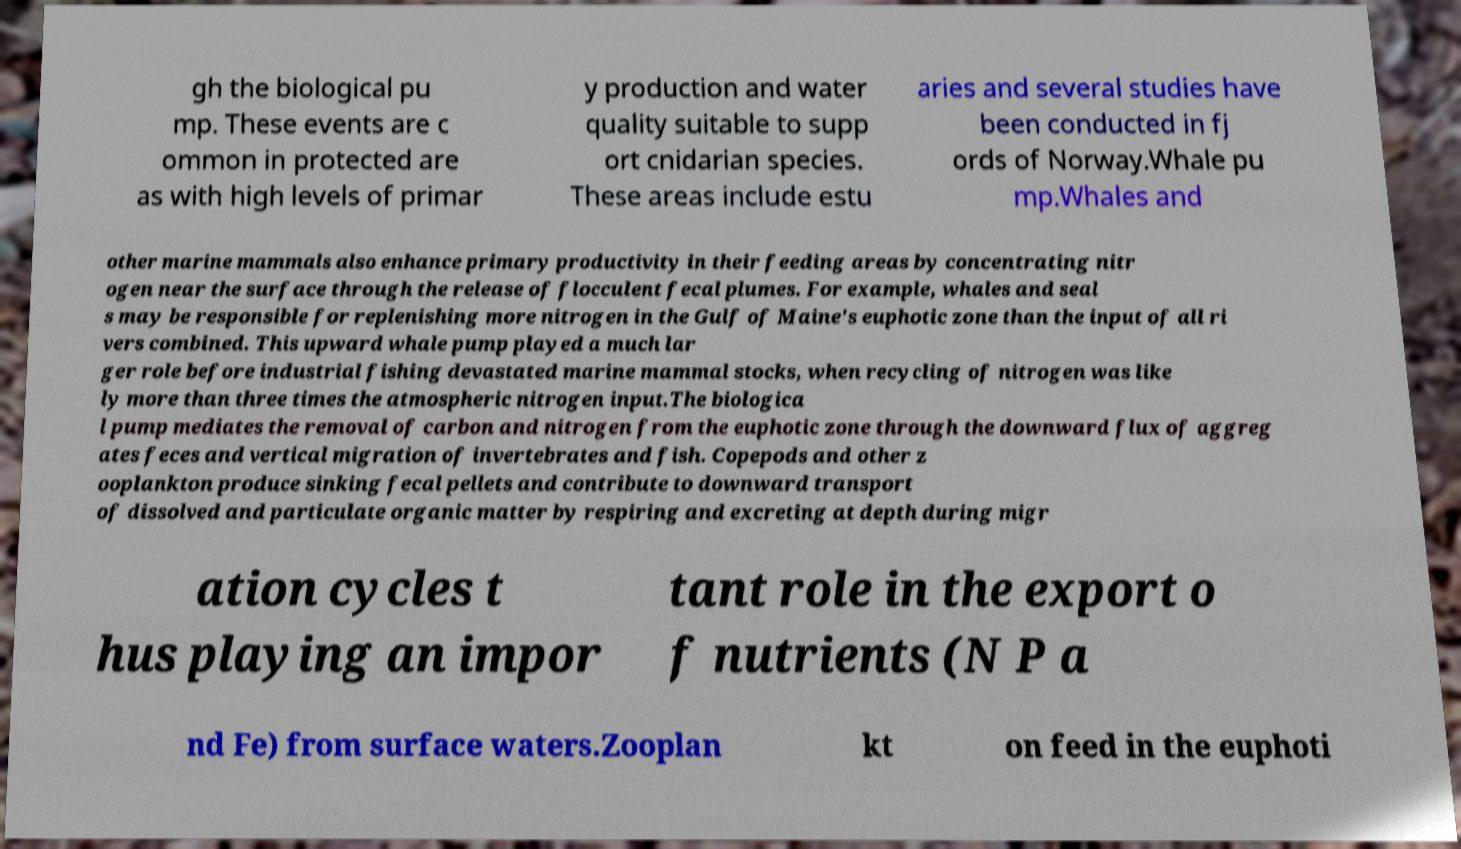Can you accurately transcribe the text from the provided image for me? gh the biological pu mp. These events are c ommon in protected are as with high levels of primar y production and water quality suitable to supp ort cnidarian species. These areas include estu aries and several studies have been conducted in fj ords of Norway.Whale pu mp.Whales and other marine mammals also enhance primary productivity in their feeding areas by concentrating nitr ogen near the surface through the release of flocculent fecal plumes. For example, whales and seal s may be responsible for replenishing more nitrogen in the Gulf of Maine's euphotic zone than the input of all ri vers combined. This upward whale pump played a much lar ger role before industrial fishing devastated marine mammal stocks, when recycling of nitrogen was like ly more than three times the atmospheric nitrogen input.The biologica l pump mediates the removal of carbon and nitrogen from the euphotic zone through the downward flux of aggreg ates feces and vertical migration of invertebrates and fish. Copepods and other z ooplankton produce sinking fecal pellets and contribute to downward transport of dissolved and particulate organic matter by respiring and excreting at depth during migr ation cycles t hus playing an impor tant role in the export o f nutrients (N P a nd Fe) from surface waters.Zooplan kt on feed in the euphoti 